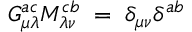<formula> <loc_0><loc_0><loc_500><loc_500>G _ { \mu \lambda } ^ { a c } M _ { \lambda \nu } ^ { c b } \, = \, \delta _ { \mu \nu } \delta ^ { a b }</formula> 